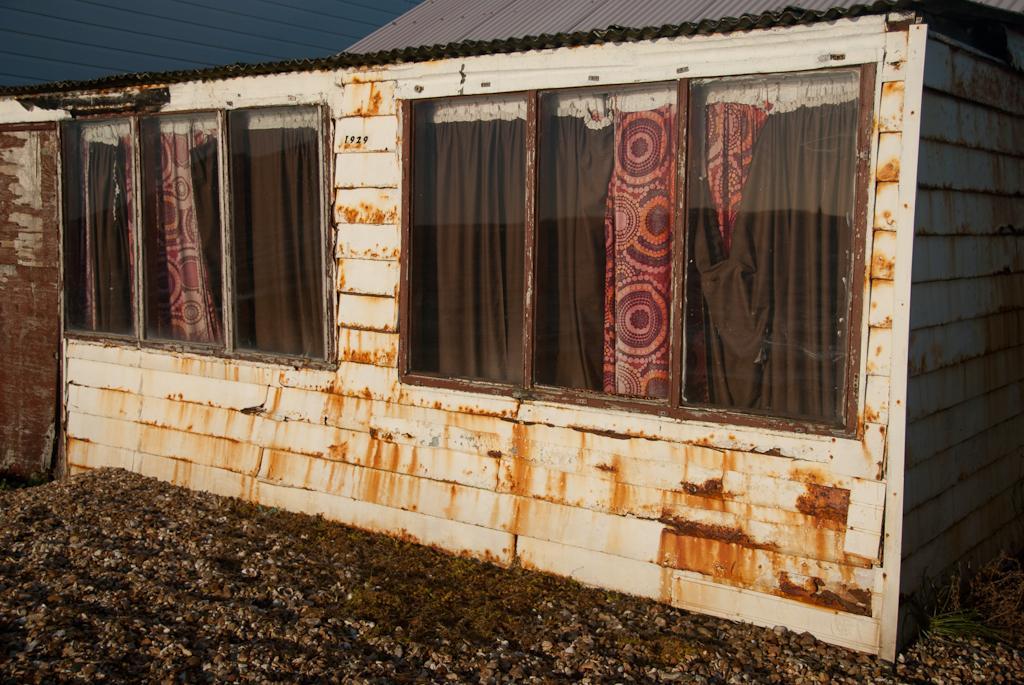In one or two sentences, can you explain what this image depicts? In this image we can see a building with brick wall and windows. Through the windows we can see curtains. 